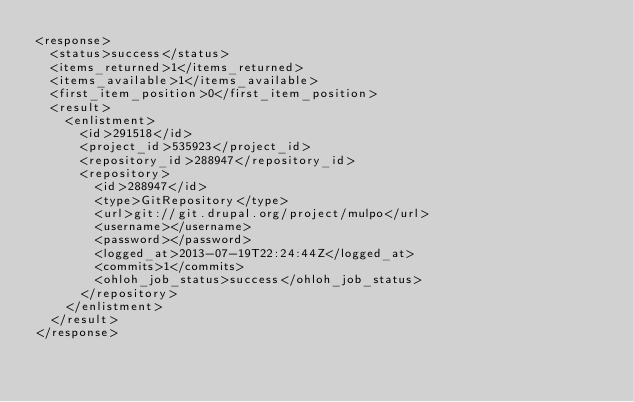Convert code to text. <code><loc_0><loc_0><loc_500><loc_500><_XML_><response>
  <status>success</status>
  <items_returned>1</items_returned>
  <items_available>1</items_available>
  <first_item_position>0</first_item_position>
  <result>
    <enlistment>
      <id>291518</id>
      <project_id>535923</project_id>
      <repository_id>288947</repository_id>
      <repository>
        <id>288947</id>
        <type>GitRepository</type>
        <url>git://git.drupal.org/project/mulpo</url>
        <username></username>
        <password></password>
        <logged_at>2013-07-19T22:24:44Z</logged_at>
        <commits>1</commits>
        <ohloh_job_status>success</ohloh_job_status>
      </repository>
    </enlistment>
  </result>
</response>
</code> 